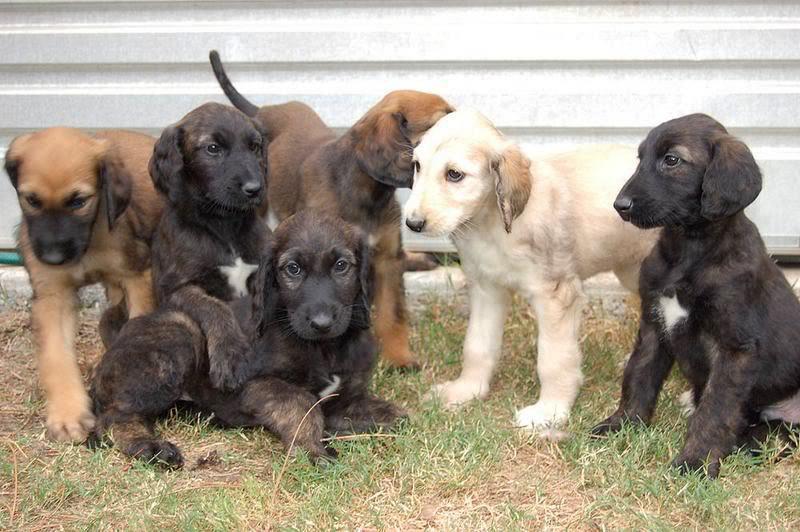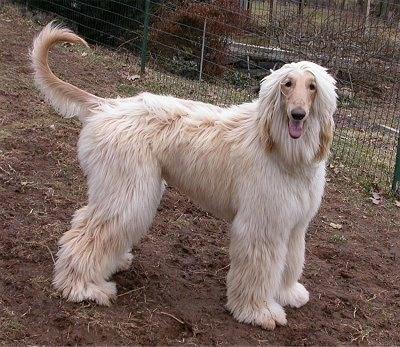The first image is the image on the left, the second image is the image on the right. For the images shown, is this caption "There is a group of dogs in one of the images." true? Answer yes or no. Yes. The first image is the image on the left, the second image is the image on the right. Given the left and right images, does the statement "One image contains at least five dogs, with varying fur coloration." hold true? Answer yes or no. Yes. 